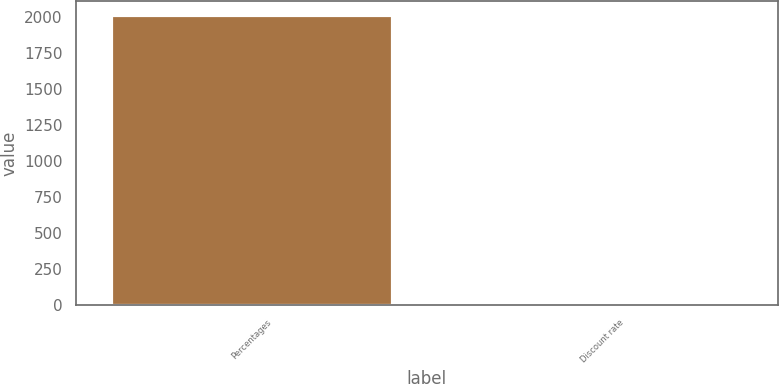Convert chart to OTSL. <chart><loc_0><loc_0><loc_500><loc_500><bar_chart><fcel>Percentages<fcel>Discount rate<nl><fcel>2013<fcel>3.4<nl></chart> 